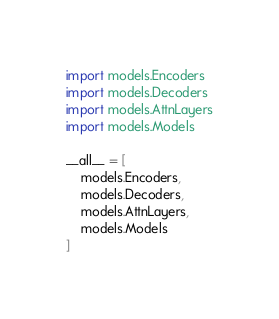<code> <loc_0><loc_0><loc_500><loc_500><_Python_>import models.Encoders
import models.Decoders
import models.AttnLayers
import models.Models

__all__ = [
    models.Encoders,
    models.Decoders,
    models.AttnLayers,
    models.Models
]
</code> 